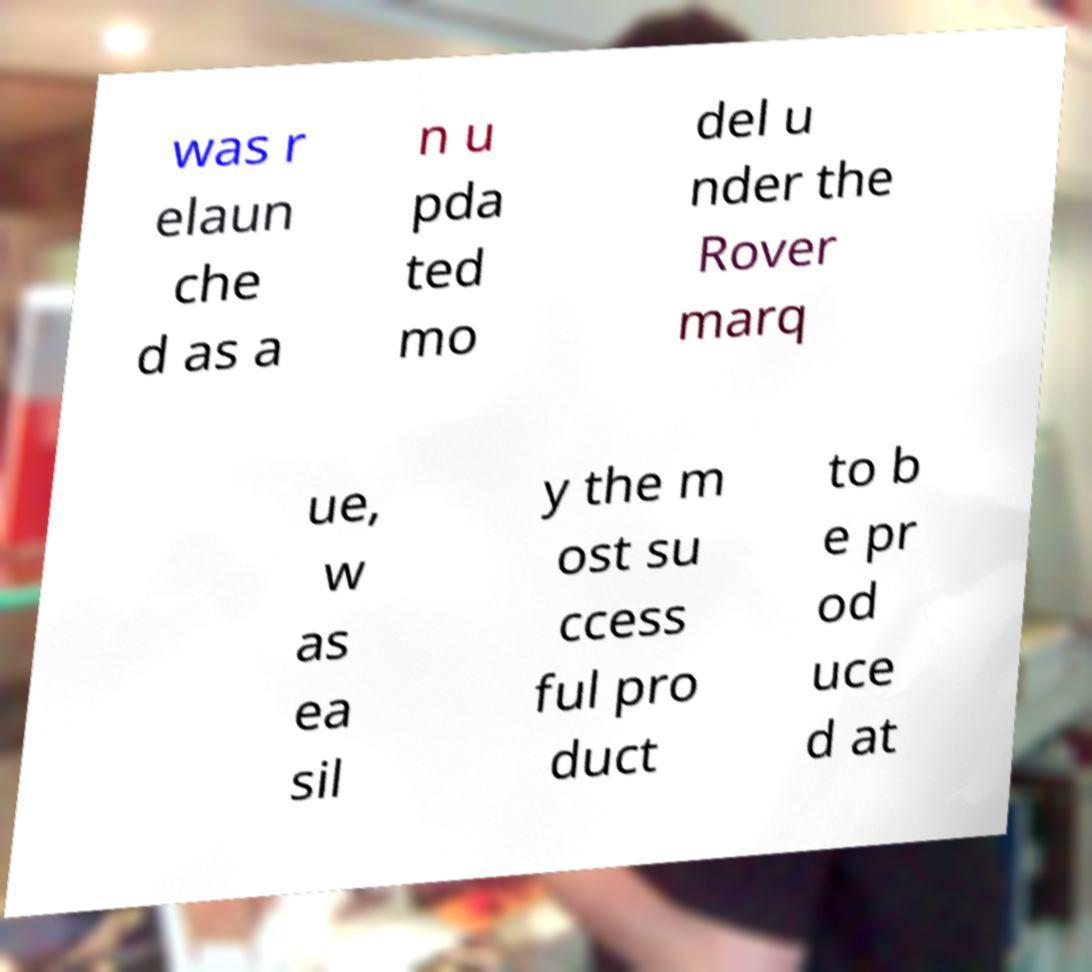Can you accurately transcribe the text from the provided image for me? was r elaun che d as a n u pda ted mo del u nder the Rover marq ue, w as ea sil y the m ost su ccess ful pro duct to b e pr od uce d at 